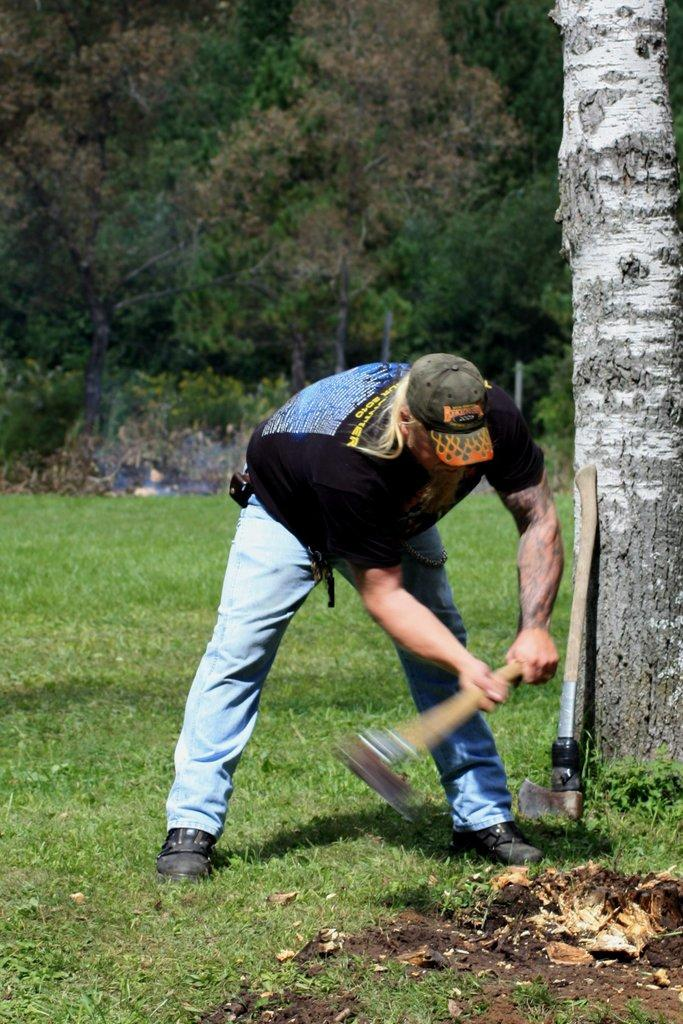Who is present in the image? There is a person in the image. What is the person holding in the image? The person is holding an axe. Can you describe the other axe in the image? There is another axe on the ground in the image. What type of structures can be seen in the image? There are poles in the image. What natural elements are visible in the image? There are trees and grass in the image. How does the person look while performing the test in the image? There is no test being performed in the image; the person is simply holding an axe. 